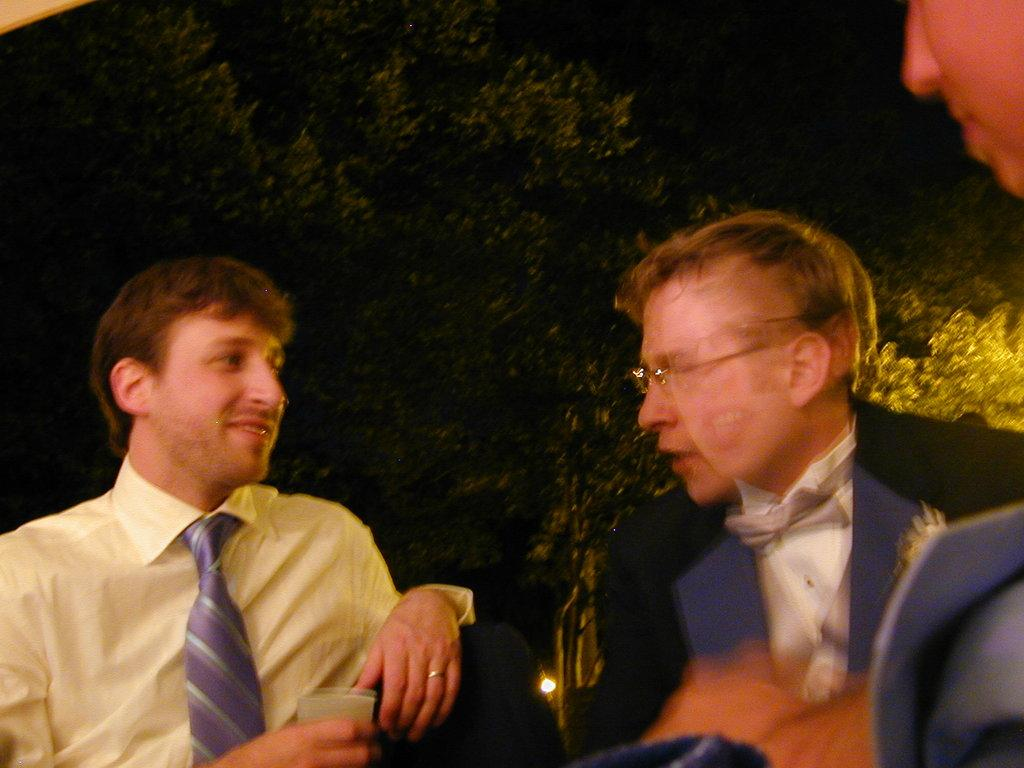How many people are in the image? There are a few people in the image. What is one of the people holding in the image? One of the people is holding a glass. What type of natural vegetation is visible in the image? There are trees in the image. What is the source of illumination in the image? There is a light in the image. What type of meal is being prepared in the image? There is no indication in the image that a meal is being prepared. What type of vegetable is being served in the image? There is no vegetable present in the image. 